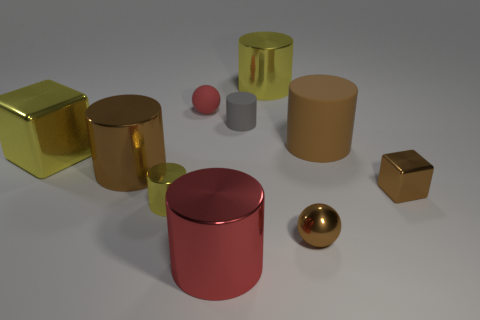What color is the other cube that is made of the same material as the large cube?
Provide a short and direct response. Brown. Are there fewer tiny rubber cylinders on the left side of the red metal thing than small matte balls?
Ensure brevity in your answer.  Yes. There is a shiny cube that is behind the cube that is to the right of the metallic cylinder on the right side of the red cylinder; what is its size?
Provide a short and direct response. Large. Is the big brown object behind the big yellow metallic cube made of the same material as the brown cube?
Keep it short and to the point. No. What material is the large thing that is the same color as the large metal cube?
Offer a terse response. Metal. What number of things are brown metal spheres or yellow shiny cylinders?
Keep it short and to the point. 3. What size is the gray rubber object that is the same shape as the large red shiny thing?
Your answer should be very brief. Small. How many other things are the same color as the tiny metallic ball?
Provide a succinct answer. 3. How many cylinders are large green metal things or small gray rubber things?
Your answer should be very brief. 1. What is the color of the metallic cube that is to the right of the yellow cylinder that is behind the large brown rubber thing?
Provide a succinct answer. Brown. 